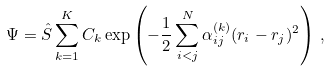Convert formula to latex. <formula><loc_0><loc_0><loc_500><loc_500>\Psi = \hat { S } \sum _ { k = 1 } ^ { K } C _ { k } \exp \left ( - \frac { 1 } { 2 } \sum _ { i < j } ^ { N } \alpha _ { i j } ^ { ( k ) } ( r _ { i } - r _ { j } ) ^ { 2 } \right ) \, ,</formula> 